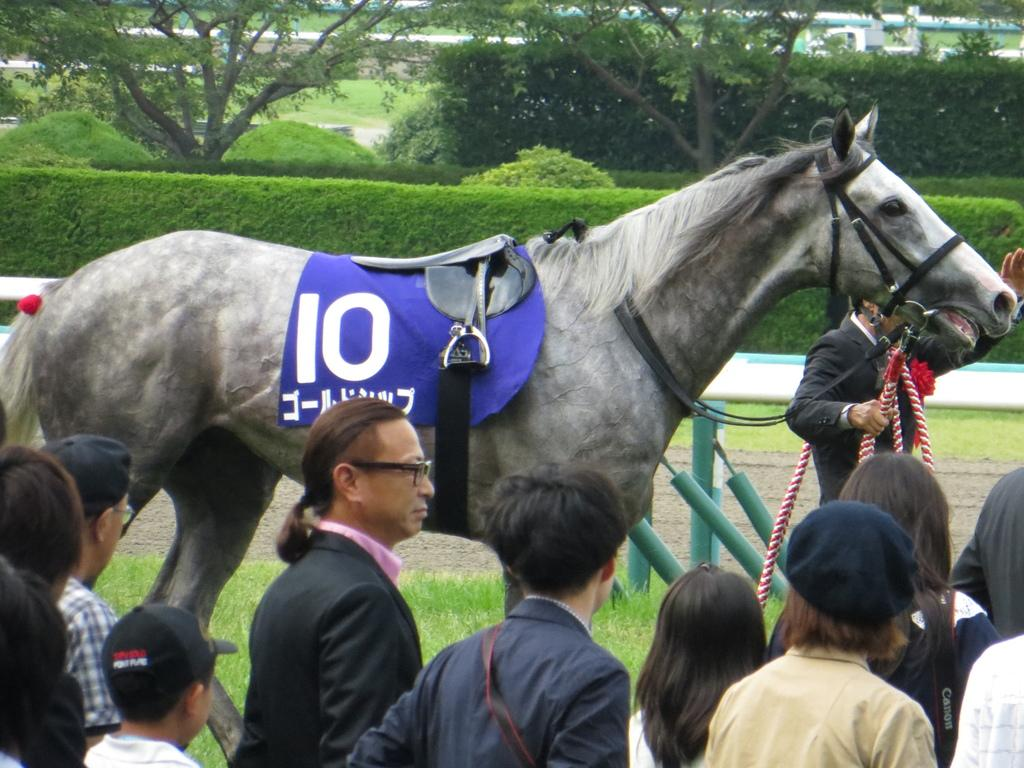What animal is present in the image? There is a horse in the image. What is attached to the horse? There is a paddle on the horse. Who is near the horse? There is a person standing near the horse. How many people are in the image? There is a group of people standing in the image. What type of vegetation is visible in the image? There are trees and grass in the image. What knowledge does the horse possess about the plough in the image? A: There is no plough present in the image, and horses do not possess knowledge in the same way humans do. 